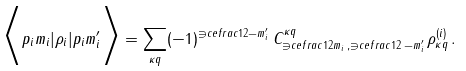Convert formula to latex. <formula><loc_0><loc_0><loc_500><loc_500>\Big < p _ { i } m _ { i } | { \rho } _ { i } | p _ { i } m _ { i } ^ { \prime } \Big > = \sum _ { \kappa q } ( - 1 ) ^ { \ni c e f r a c { 1 } { 2 } - m _ { i } ^ { \prime } } \, C _ { \ni c e f r a c { 1 } { 2 } m _ { i } \, , \ni c e f r a c { 1 } { 2 } \, - m _ { i } ^ { \prime } } ^ { \kappa q } \, \rho ^ { ( i ) } _ { \kappa q } \, .</formula> 